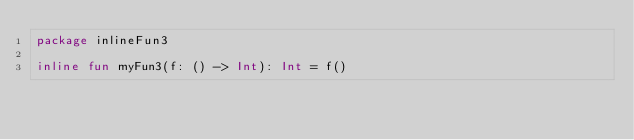Convert code to text. <code><loc_0><loc_0><loc_500><loc_500><_Kotlin_>package inlineFun3

inline fun myFun3(f: () -> Int): Int = f()</code> 